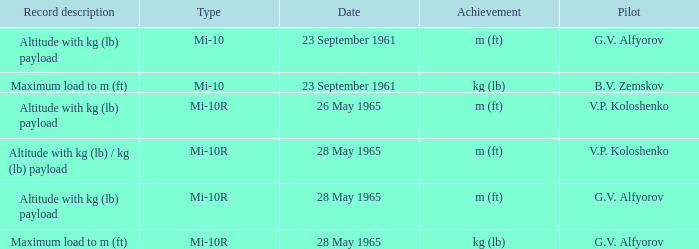Date of 23 september 1961, and a Pilot of b.v. zemskov had what record description? Maximum load to m (ft). 